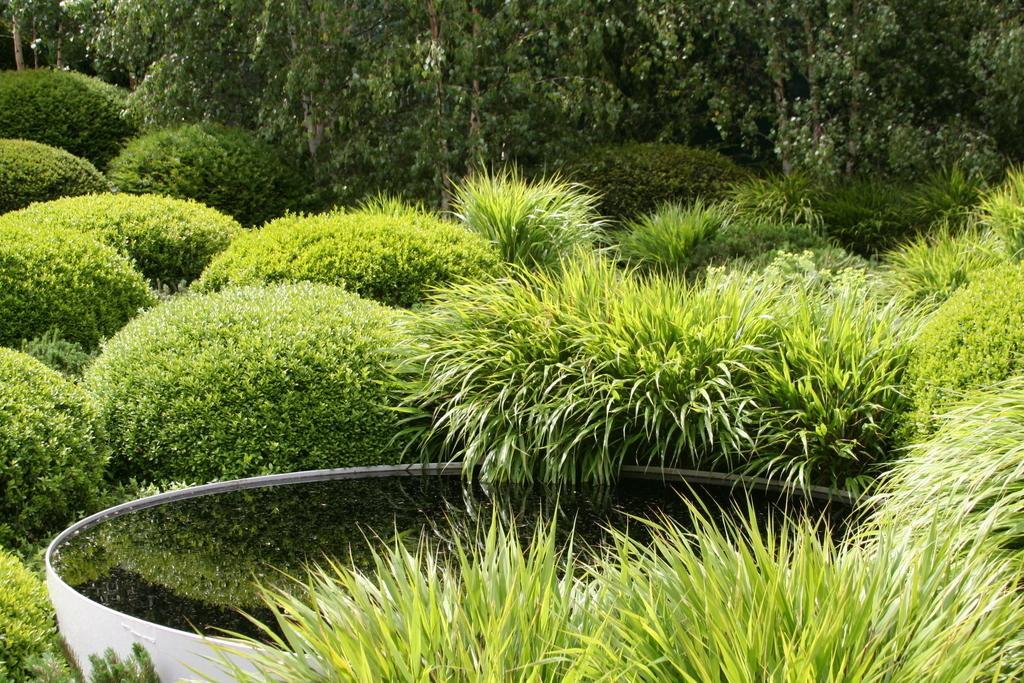Can you describe this image briefly? In this picture we can see there is water in an item. Behind the item there are bushes and trees. 